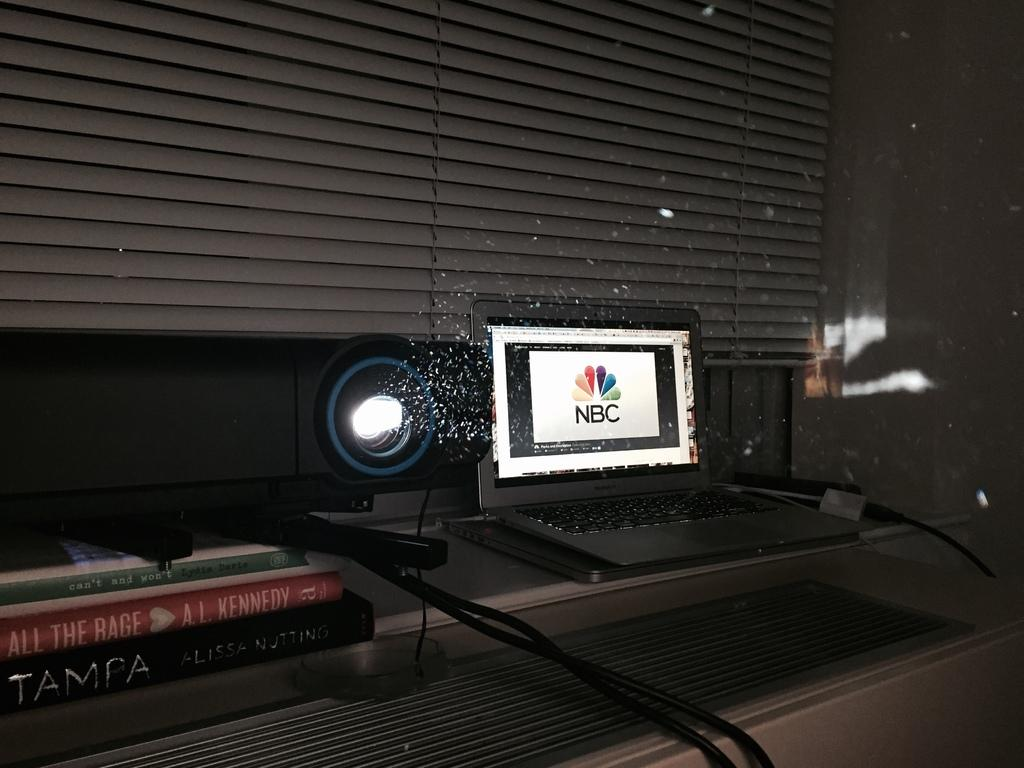<image>
Share a concise interpretation of the image provided. NBC being displayed on the laptop going through the projecter. 